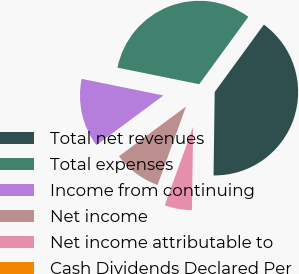Convert chart to OTSL. <chart><loc_0><loc_0><loc_500><loc_500><pie_chart><fcel>Total net revenues<fcel>Total expenses<fcel>Income from continuing<fcel>Net income<fcel>Net income attributable to<fcel>Cash Dividends Declared Per<nl><fcel>40.19%<fcel>31.84%<fcel>13.34%<fcel>9.32%<fcel>5.3%<fcel>0.01%<nl></chart> 